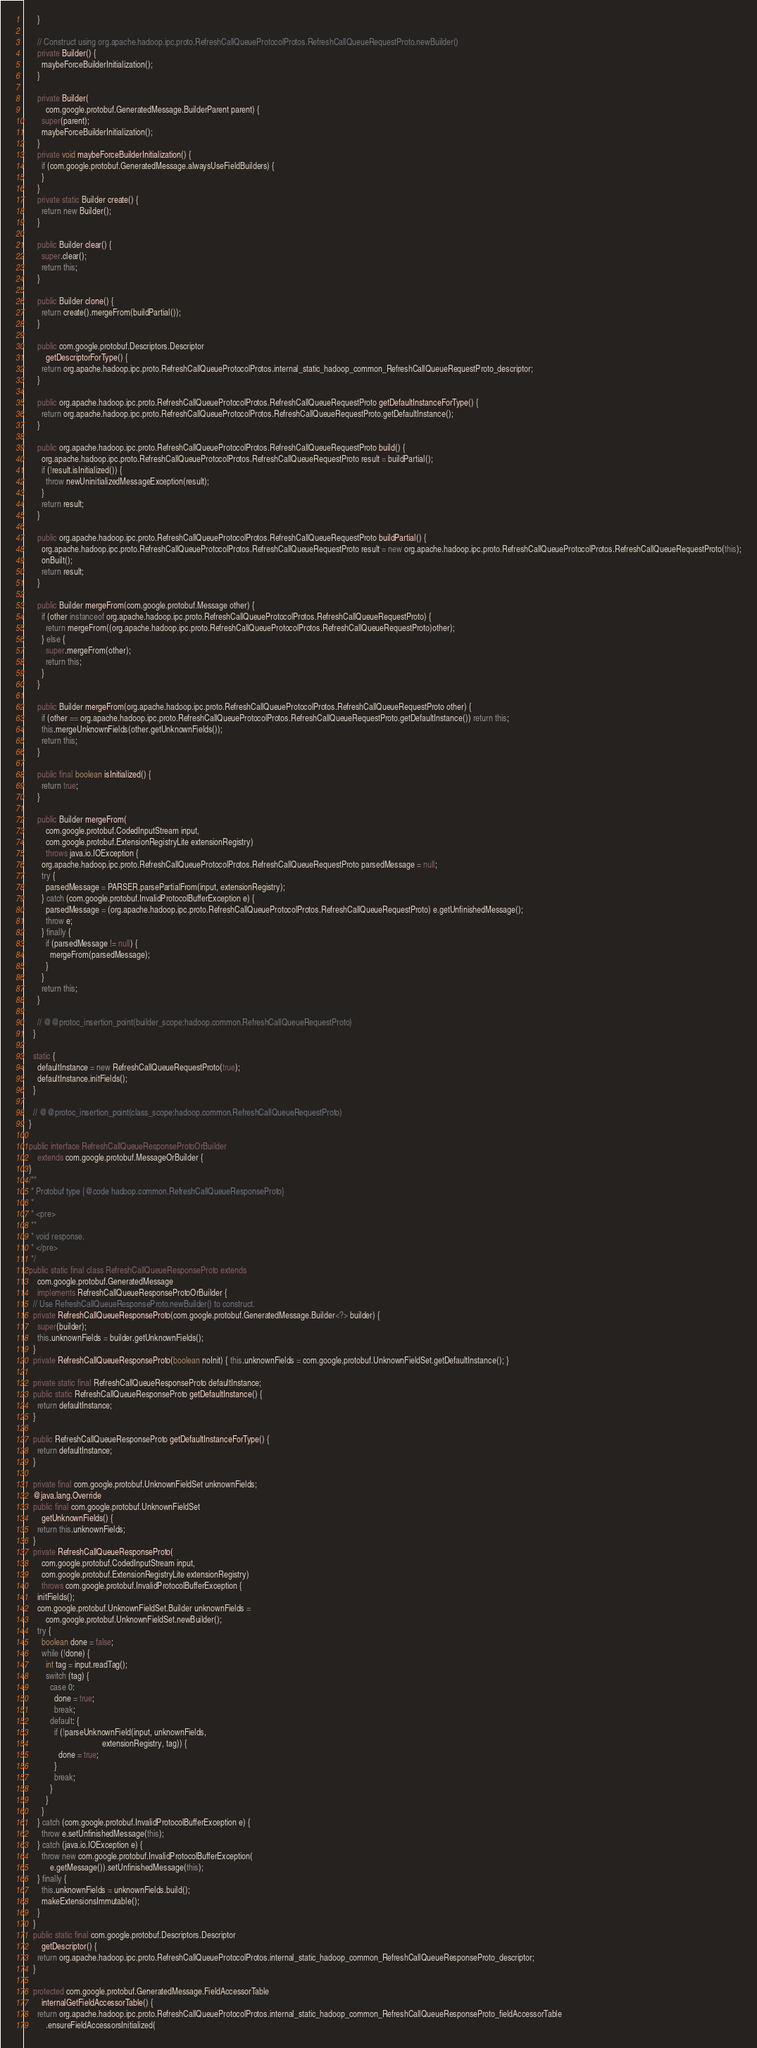<code> <loc_0><loc_0><loc_500><loc_500><_Java_>      }

      // Construct using org.apache.hadoop.ipc.proto.RefreshCallQueueProtocolProtos.RefreshCallQueueRequestProto.newBuilder()
      private Builder() {
        maybeForceBuilderInitialization();
      }

      private Builder(
          com.google.protobuf.GeneratedMessage.BuilderParent parent) {
        super(parent);
        maybeForceBuilderInitialization();
      }
      private void maybeForceBuilderInitialization() {
        if (com.google.protobuf.GeneratedMessage.alwaysUseFieldBuilders) {
        }
      }
      private static Builder create() {
        return new Builder();
      }

      public Builder clear() {
        super.clear();
        return this;
      }

      public Builder clone() {
        return create().mergeFrom(buildPartial());
      }

      public com.google.protobuf.Descriptors.Descriptor
          getDescriptorForType() {
        return org.apache.hadoop.ipc.proto.RefreshCallQueueProtocolProtos.internal_static_hadoop_common_RefreshCallQueueRequestProto_descriptor;
      }

      public org.apache.hadoop.ipc.proto.RefreshCallQueueProtocolProtos.RefreshCallQueueRequestProto getDefaultInstanceForType() {
        return org.apache.hadoop.ipc.proto.RefreshCallQueueProtocolProtos.RefreshCallQueueRequestProto.getDefaultInstance();
      }

      public org.apache.hadoop.ipc.proto.RefreshCallQueueProtocolProtos.RefreshCallQueueRequestProto build() {
        org.apache.hadoop.ipc.proto.RefreshCallQueueProtocolProtos.RefreshCallQueueRequestProto result = buildPartial();
        if (!result.isInitialized()) {
          throw newUninitializedMessageException(result);
        }
        return result;
      }

      public org.apache.hadoop.ipc.proto.RefreshCallQueueProtocolProtos.RefreshCallQueueRequestProto buildPartial() {
        org.apache.hadoop.ipc.proto.RefreshCallQueueProtocolProtos.RefreshCallQueueRequestProto result = new org.apache.hadoop.ipc.proto.RefreshCallQueueProtocolProtos.RefreshCallQueueRequestProto(this);
        onBuilt();
        return result;
      }

      public Builder mergeFrom(com.google.protobuf.Message other) {
        if (other instanceof org.apache.hadoop.ipc.proto.RefreshCallQueueProtocolProtos.RefreshCallQueueRequestProto) {
          return mergeFrom((org.apache.hadoop.ipc.proto.RefreshCallQueueProtocolProtos.RefreshCallQueueRequestProto)other);
        } else {
          super.mergeFrom(other);
          return this;
        }
      }

      public Builder mergeFrom(org.apache.hadoop.ipc.proto.RefreshCallQueueProtocolProtos.RefreshCallQueueRequestProto other) {
        if (other == org.apache.hadoop.ipc.proto.RefreshCallQueueProtocolProtos.RefreshCallQueueRequestProto.getDefaultInstance()) return this;
        this.mergeUnknownFields(other.getUnknownFields());
        return this;
      }

      public final boolean isInitialized() {
        return true;
      }

      public Builder mergeFrom(
          com.google.protobuf.CodedInputStream input,
          com.google.protobuf.ExtensionRegistryLite extensionRegistry)
          throws java.io.IOException {
        org.apache.hadoop.ipc.proto.RefreshCallQueueProtocolProtos.RefreshCallQueueRequestProto parsedMessage = null;
        try {
          parsedMessage = PARSER.parsePartialFrom(input, extensionRegistry);
        } catch (com.google.protobuf.InvalidProtocolBufferException e) {
          parsedMessage = (org.apache.hadoop.ipc.proto.RefreshCallQueueProtocolProtos.RefreshCallQueueRequestProto) e.getUnfinishedMessage();
          throw e;
        } finally {
          if (parsedMessage != null) {
            mergeFrom(parsedMessage);
          }
        }
        return this;
      }

      // @@protoc_insertion_point(builder_scope:hadoop.common.RefreshCallQueueRequestProto)
    }

    static {
      defaultInstance = new RefreshCallQueueRequestProto(true);
      defaultInstance.initFields();
    }

    // @@protoc_insertion_point(class_scope:hadoop.common.RefreshCallQueueRequestProto)
  }

  public interface RefreshCallQueueResponseProtoOrBuilder
      extends com.google.protobuf.MessageOrBuilder {
  }
  /**
   * Protobuf type {@code hadoop.common.RefreshCallQueueResponseProto}
   *
   * <pre>
   **
   * void response.
   * </pre>
   */
  public static final class RefreshCallQueueResponseProto extends
      com.google.protobuf.GeneratedMessage
      implements RefreshCallQueueResponseProtoOrBuilder {
    // Use RefreshCallQueueResponseProto.newBuilder() to construct.
    private RefreshCallQueueResponseProto(com.google.protobuf.GeneratedMessage.Builder<?> builder) {
      super(builder);
      this.unknownFields = builder.getUnknownFields();
    }
    private RefreshCallQueueResponseProto(boolean noInit) { this.unknownFields = com.google.protobuf.UnknownFieldSet.getDefaultInstance(); }

    private static final RefreshCallQueueResponseProto defaultInstance;
    public static RefreshCallQueueResponseProto getDefaultInstance() {
      return defaultInstance;
    }

    public RefreshCallQueueResponseProto getDefaultInstanceForType() {
      return defaultInstance;
    }

    private final com.google.protobuf.UnknownFieldSet unknownFields;
    @java.lang.Override
    public final com.google.protobuf.UnknownFieldSet
        getUnknownFields() {
      return this.unknownFields;
    }
    private RefreshCallQueueResponseProto(
        com.google.protobuf.CodedInputStream input,
        com.google.protobuf.ExtensionRegistryLite extensionRegistry)
        throws com.google.protobuf.InvalidProtocolBufferException {
      initFields();
      com.google.protobuf.UnknownFieldSet.Builder unknownFields =
          com.google.protobuf.UnknownFieldSet.newBuilder();
      try {
        boolean done = false;
        while (!done) {
          int tag = input.readTag();
          switch (tag) {
            case 0:
              done = true;
              break;
            default: {
              if (!parseUnknownField(input, unknownFields,
                                     extensionRegistry, tag)) {
                done = true;
              }
              break;
            }
          }
        }
      } catch (com.google.protobuf.InvalidProtocolBufferException e) {
        throw e.setUnfinishedMessage(this);
      } catch (java.io.IOException e) {
        throw new com.google.protobuf.InvalidProtocolBufferException(
            e.getMessage()).setUnfinishedMessage(this);
      } finally {
        this.unknownFields = unknownFields.build();
        makeExtensionsImmutable();
      }
    }
    public static final com.google.protobuf.Descriptors.Descriptor
        getDescriptor() {
      return org.apache.hadoop.ipc.proto.RefreshCallQueueProtocolProtos.internal_static_hadoop_common_RefreshCallQueueResponseProto_descriptor;
    }

    protected com.google.protobuf.GeneratedMessage.FieldAccessorTable
        internalGetFieldAccessorTable() {
      return org.apache.hadoop.ipc.proto.RefreshCallQueueProtocolProtos.internal_static_hadoop_common_RefreshCallQueueResponseProto_fieldAccessorTable
          .ensureFieldAccessorsInitialized(</code> 